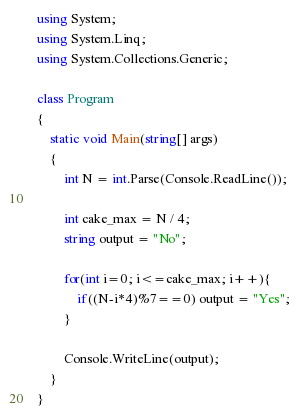Convert code to text. <code><loc_0><loc_0><loc_500><loc_500><_C#_>    using System;
    using System.Linq;
    using System.Collections.Generic;
     
    class Program
    {
        static void Main(string[] args)
        {
            int N = int.Parse(Console.ReadLine());

            int cake_max = N / 4;
            string output = "No";

            for(int i=0; i<=cake_max; i++){
                if((N-i*4)%7==0) output = "Yes";
            }

            Console.WriteLine(output);
        }
    }</code> 